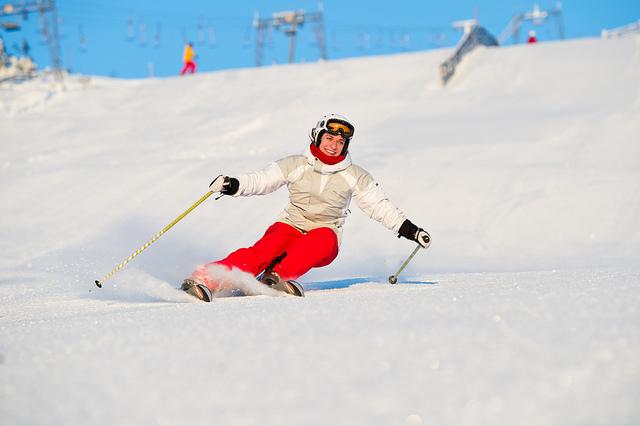What is in the picture?
Keep it brief. Skier. Is it cold?
Keep it brief. Yes. What is the height of the mountain off in the distance?
Write a very short answer. High. Does this skier look happy?
Short answer required. Yes. 